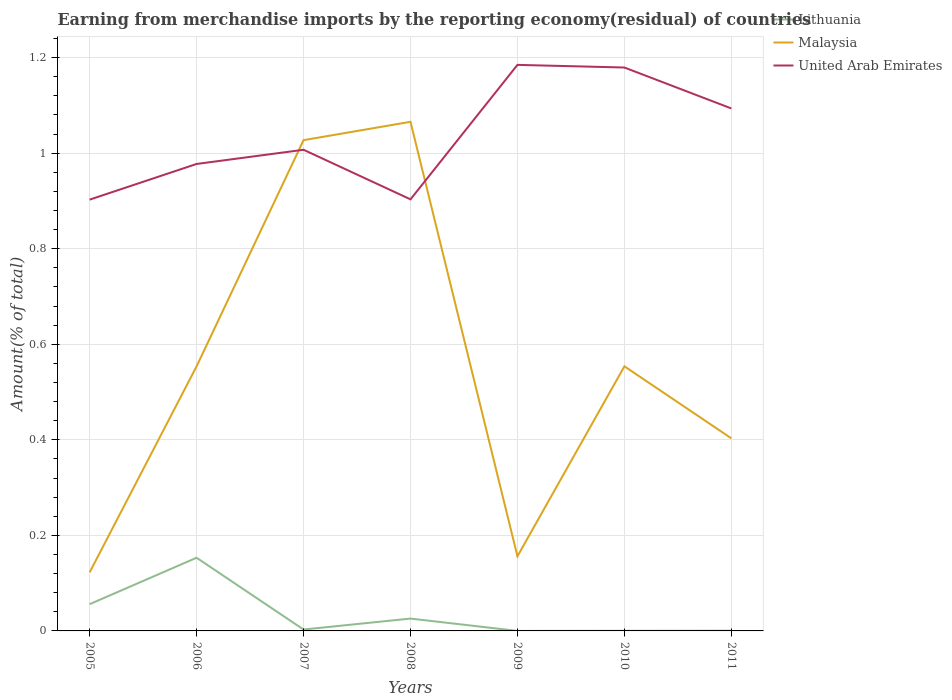How many different coloured lines are there?
Your response must be concise. 3. Does the line corresponding to United Arab Emirates intersect with the line corresponding to Lithuania?
Your answer should be compact. No. Is the number of lines equal to the number of legend labels?
Your answer should be compact. Yes. Across all years, what is the maximum percentage of amount earned from merchandise imports in Malaysia?
Your answer should be compact. 0.12. What is the total percentage of amount earned from merchandise imports in United Arab Emirates in the graph?
Make the answer very short. -0.17. What is the difference between the highest and the second highest percentage of amount earned from merchandise imports in United Arab Emirates?
Provide a short and direct response. 0.28. Is the percentage of amount earned from merchandise imports in Lithuania strictly greater than the percentage of amount earned from merchandise imports in United Arab Emirates over the years?
Offer a terse response. Yes. How many lines are there?
Give a very brief answer. 3. How many years are there in the graph?
Offer a very short reply. 7. What is the difference between two consecutive major ticks on the Y-axis?
Keep it short and to the point. 0.2. Does the graph contain any zero values?
Your answer should be very brief. No. How many legend labels are there?
Offer a terse response. 3. What is the title of the graph?
Offer a terse response. Earning from merchandise imports by the reporting economy(residual) of countries. What is the label or title of the Y-axis?
Your answer should be compact. Amount(% of total). What is the Amount(% of total) in Lithuania in 2005?
Keep it short and to the point. 0.06. What is the Amount(% of total) of Malaysia in 2005?
Provide a short and direct response. 0.12. What is the Amount(% of total) of United Arab Emirates in 2005?
Keep it short and to the point. 0.9. What is the Amount(% of total) of Lithuania in 2006?
Keep it short and to the point. 0.15. What is the Amount(% of total) of Malaysia in 2006?
Give a very brief answer. 0.55. What is the Amount(% of total) in United Arab Emirates in 2006?
Your answer should be very brief. 0.98. What is the Amount(% of total) of Lithuania in 2007?
Provide a short and direct response. 0. What is the Amount(% of total) in Malaysia in 2007?
Make the answer very short. 1.03. What is the Amount(% of total) in United Arab Emirates in 2007?
Offer a terse response. 1.01. What is the Amount(% of total) of Lithuania in 2008?
Your response must be concise. 0.03. What is the Amount(% of total) of Malaysia in 2008?
Your response must be concise. 1.07. What is the Amount(% of total) of United Arab Emirates in 2008?
Give a very brief answer. 0.9. What is the Amount(% of total) in Lithuania in 2009?
Your response must be concise. 1.744827181737909e-5. What is the Amount(% of total) in Malaysia in 2009?
Offer a terse response. 0.16. What is the Amount(% of total) in United Arab Emirates in 2009?
Offer a very short reply. 1.18. What is the Amount(% of total) of Lithuania in 2010?
Offer a terse response. 0. What is the Amount(% of total) of Malaysia in 2010?
Your answer should be compact. 0.55. What is the Amount(% of total) of United Arab Emirates in 2010?
Your response must be concise. 1.18. What is the Amount(% of total) of Lithuania in 2011?
Provide a short and direct response. 0. What is the Amount(% of total) in Malaysia in 2011?
Give a very brief answer. 0.4. What is the Amount(% of total) of United Arab Emirates in 2011?
Make the answer very short. 1.09. Across all years, what is the maximum Amount(% of total) in Lithuania?
Your answer should be compact. 0.15. Across all years, what is the maximum Amount(% of total) of Malaysia?
Your answer should be very brief. 1.07. Across all years, what is the maximum Amount(% of total) in United Arab Emirates?
Provide a succinct answer. 1.18. Across all years, what is the minimum Amount(% of total) in Lithuania?
Offer a very short reply. 1.744827181737909e-5. Across all years, what is the minimum Amount(% of total) in Malaysia?
Keep it short and to the point. 0.12. Across all years, what is the minimum Amount(% of total) of United Arab Emirates?
Your response must be concise. 0.9. What is the total Amount(% of total) of Lithuania in the graph?
Your answer should be compact. 0.24. What is the total Amount(% of total) of Malaysia in the graph?
Keep it short and to the point. 3.88. What is the total Amount(% of total) in United Arab Emirates in the graph?
Your answer should be very brief. 7.25. What is the difference between the Amount(% of total) in Lithuania in 2005 and that in 2006?
Provide a succinct answer. -0.1. What is the difference between the Amount(% of total) of Malaysia in 2005 and that in 2006?
Your response must be concise. -0.43. What is the difference between the Amount(% of total) in United Arab Emirates in 2005 and that in 2006?
Offer a terse response. -0.07. What is the difference between the Amount(% of total) in Lithuania in 2005 and that in 2007?
Provide a succinct answer. 0.05. What is the difference between the Amount(% of total) in Malaysia in 2005 and that in 2007?
Provide a short and direct response. -0.9. What is the difference between the Amount(% of total) in United Arab Emirates in 2005 and that in 2007?
Make the answer very short. -0.1. What is the difference between the Amount(% of total) in Lithuania in 2005 and that in 2008?
Your answer should be compact. 0.03. What is the difference between the Amount(% of total) in Malaysia in 2005 and that in 2008?
Your answer should be very brief. -0.94. What is the difference between the Amount(% of total) of United Arab Emirates in 2005 and that in 2008?
Make the answer very short. -0. What is the difference between the Amount(% of total) in Lithuania in 2005 and that in 2009?
Give a very brief answer. 0.06. What is the difference between the Amount(% of total) in Malaysia in 2005 and that in 2009?
Your answer should be very brief. -0.03. What is the difference between the Amount(% of total) of United Arab Emirates in 2005 and that in 2009?
Keep it short and to the point. -0.28. What is the difference between the Amount(% of total) in Lithuania in 2005 and that in 2010?
Your response must be concise. 0.06. What is the difference between the Amount(% of total) of Malaysia in 2005 and that in 2010?
Give a very brief answer. -0.43. What is the difference between the Amount(% of total) in United Arab Emirates in 2005 and that in 2010?
Provide a short and direct response. -0.28. What is the difference between the Amount(% of total) in Lithuania in 2005 and that in 2011?
Keep it short and to the point. 0.06. What is the difference between the Amount(% of total) in Malaysia in 2005 and that in 2011?
Give a very brief answer. -0.28. What is the difference between the Amount(% of total) in United Arab Emirates in 2005 and that in 2011?
Keep it short and to the point. -0.19. What is the difference between the Amount(% of total) of Lithuania in 2006 and that in 2007?
Ensure brevity in your answer.  0.15. What is the difference between the Amount(% of total) of Malaysia in 2006 and that in 2007?
Make the answer very short. -0.47. What is the difference between the Amount(% of total) in United Arab Emirates in 2006 and that in 2007?
Make the answer very short. -0.03. What is the difference between the Amount(% of total) in Lithuania in 2006 and that in 2008?
Keep it short and to the point. 0.13. What is the difference between the Amount(% of total) in Malaysia in 2006 and that in 2008?
Keep it short and to the point. -0.51. What is the difference between the Amount(% of total) of United Arab Emirates in 2006 and that in 2008?
Give a very brief answer. 0.07. What is the difference between the Amount(% of total) of Lithuania in 2006 and that in 2009?
Keep it short and to the point. 0.15. What is the difference between the Amount(% of total) of Malaysia in 2006 and that in 2009?
Your answer should be compact. 0.4. What is the difference between the Amount(% of total) in United Arab Emirates in 2006 and that in 2009?
Offer a terse response. -0.21. What is the difference between the Amount(% of total) in Lithuania in 2006 and that in 2010?
Offer a terse response. 0.15. What is the difference between the Amount(% of total) of Malaysia in 2006 and that in 2010?
Ensure brevity in your answer.  -0. What is the difference between the Amount(% of total) of United Arab Emirates in 2006 and that in 2010?
Provide a short and direct response. -0.2. What is the difference between the Amount(% of total) of Lithuania in 2006 and that in 2011?
Make the answer very short. 0.15. What is the difference between the Amount(% of total) of Malaysia in 2006 and that in 2011?
Make the answer very short. 0.15. What is the difference between the Amount(% of total) in United Arab Emirates in 2006 and that in 2011?
Offer a very short reply. -0.12. What is the difference between the Amount(% of total) of Lithuania in 2007 and that in 2008?
Give a very brief answer. -0.02. What is the difference between the Amount(% of total) in Malaysia in 2007 and that in 2008?
Your answer should be compact. -0.04. What is the difference between the Amount(% of total) in United Arab Emirates in 2007 and that in 2008?
Give a very brief answer. 0.1. What is the difference between the Amount(% of total) in Lithuania in 2007 and that in 2009?
Provide a succinct answer. 0. What is the difference between the Amount(% of total) of Malaysia in 2007 and that in 2009?
Give a very brief answer. 0.87. What is the difference between the Amount(% of total) of United Arab Emirates in 2007 and that in 2009?
Offer a very short reply. -0.18. What is the difference between the Amount(% of total) in Lithuania in 2007 and that in 2010?
Your answer should be very brief. 0. What is the difference between the Amount(% of total) of Malaysia in 2007 and that in 2010?
Ensure brevity in your answer.  0.47. What is the difference between the Amount(% of total) in United Arab Emirates in 2007 and that in 2010?
Provide a succinct answer. -0.17. What is the difference between the Amount(% of total) of Lithuania in 2007 and that in 2011?
Your answer should be very brief. 0. What is the difference between the Amount(% of total) of Malaysia in 2007 and that in 2011?
Offer a terse response. 0.62. What is the difference between the Amount(% of total) of United Arab Emirates in 2007 and that in 2011?
Provide a short and direct response. -0.09. What is the difference between the Amount(% of total) of Lithuania in 2008 and that in 2009?
Your answer should be very brief. 0.03. What is the difference between the Amount(% of total) of Malaysia in 2008 and that in 2009?
Give a very brief answer. 0.91. What is the difference between the Amount(% of total) in United Arab Emirates in 2008 and that in 2009?
Ensure brevity in your answer.  -0.28. What is the difference between the Amount(% of total) of Lithuania in 2008 and that in 2010?
Keep it short and to the point. 0.03. What is the difference between the Amount(% of total) of Malaysia in 2008 and that in 2010?
Give a very brief answer. 0.51. What is the difference between the Amount(% of total) of United Arab Emirates in 2008 and that in 2010?
Your answer should be compact. -0.28. What is the difference between the Amount(% of total) of Lithuania in 2008 and that in 2011?
Ensure brevity in your answer.  0.03. What is the difference between the Amount(% of total) of Malaysia in 2008 and that in 2011?
Make the answer very short. 0.66. What is the difference between the Amount(% of total) of United Arab Emirates in 2008 and that in 2011?
Your response must be concise. -0.19. What is the difference between the Amount(% of total) of Lithuania in 2009 and that in 2010?
Provide a succinct answer. -0. What is the difference between the Amount(% of total) of Malaysia in 2009 and that in 2010?
Make the answer very short. -0.4. What is the difference between the Amount(% of total) of United Arab Emirates in 2009 and that in 2010?
Ensure brevity in your answer.  0.01. What is the difference between the Amount(% of total) in Lithuania in 2009 and that in 2011?
Offer a terse response. -0. What is the difference between the Amount(% of total) in Malaysia in 2009 and that in 2011?
Your response must be concise. -0.25. What is the difference between the Amount(% of total) of United Arab Emirates in 2009 and that in 2011?
Make the answer very short. 0.09. What is the difference between the Amount(% of total) in Lithuania in 2010 and that in 2011?
Ensure brevity in your answer.  -0. What is the difference between the Amount(% of total) of Malaysia in 2010 and that in 2011?
Your response must be concise. 0.15. What is the difference between the Amount(% of total) in United Arab Emirates in 2010 and that in 2011?
Give a very brief answer. 0.09. What is the difference between the Amount(% of total) in Lithuania in 2005 and the Amount(% of total) in Malaysia in 2006?
Ensure brevity in your answer.  -0.5. What is the difference between the Amount(% of total) of Lithuania in 2005 and the Amount(% of total) of United Arab Emirates in 2006?
Make the answer very short. -0.92. What is the difference between the Amount(% of total) in Malaysia in 2005 and the Amount(% of total) in United Arab Emirates in 2006?
Keep it short and to the point. -0.85. What is the difference between the Amount(% of total) in Lithuania in 2005 and the Amount(% of total) in Malaysia in 2007?
Offer a terse response. -0.97. What is the difference between the Amount(% of total) of Lithuania in 2005 and the Amount(% of total) of United Arab Emirates in 2007?
Provide a short and direct response. -0.95. What is the difference between the Amount(% of total) of Malaysia in 2005 and the Amount(% of total) of United Arab Emirates in 2007?
Provide a succinct answer. -0.88. What is the difference between the Amount(% of total) in Lithuania in 2005 and the Amount(% of total) in Malaysia in 2008?
Make the answer very short. -1.01. What is the difference between the Amount(% of total) in Lithuania in 2005 and the Amount(% of total) in United Arab Emirates in 2008?
Your response must be concise. -0.85. What is the difference between the Amount(% of total) of Malaysia in 2005 and the Amount(% of total) of United Arab Emirates in 2008?
Your answer should be compact. -0.78. What is the difference between the Amount(% of total) of Lithuania in 2005 and the Amount(% of total) of Malaysia in 2009?
Keep it short and to the point. -0.1. What is the difference between the Amount(% of total) of Lithuania in 2005 and the Amount(% of total) of United Arab Emirates in 2009?
Offer a terse response. -1.13. What is the difference between the Amount(% of total) in Malaysia in 2005 and the Amount(% of total) in United Arab Emirates in 2009?
Give a very brief answer. -1.06. What is the difference between the Amount(% of total) in Lithuania in 2005 and the Amount(% of total) in Malaysia in 2010?
Provide a succinct answer. -0.5. What is the difference between the Amount(% of total) in Lithuania in 2005 and the Amount(% of total) in United Arab Emirates in 2010?
Ensure brevity in your answer.  -1.12. What is the difference between the Amount(% of total) of Malaysia in 2005 and the Amount(% of total) of United Arab Emirates in 2010?
Offer a terse response. -1.06. What is the difference between the Amount(% of total) of Lithuania in 2005 and the Amount(% of total) of Malaysia in 2011?
Give a very brief answer. -0.35. What is the difference between the Amount(% of total) of Lithuania in 2005 and the Amount(% of total) of United Arab Emirates in 2011?
Give a very brief answer. -1.04. What is the difference between the Amount(% of total) in Malaysia in 2005 and the Amount(% of total) in United Arab Emirates in 2011?
Make the answer very short. -0.97. What is the difference between the Amount(% of total) in Lithuania in 2006 and the Amount(% of total) in Malaysia in 2007?
Keep it short and to the point. -0.87. What is the difference between the Amount(% of total) in Lithuania in 2006 and the Amount(% of total) in United Arab Emirates in 2007?
Give a very brief answer. -0.85. What is the difference between the Amount(% of total) in Malaysia in 2006 and the Amount(% of total) in United Arab Emirates in 2007?
Ensure brevity in your answer.  -0.45. What is the difference between the Amount(% of total) in Lithuania in 2006 and the Amount(% of total) in Malaysia in 2008?
Your answer should be compact. -0.91. What is the difference between the Amount(% of total) in Lithuania in 2006 and the Amount(% of total) in United Arab Emirates in 2008?
Your response must be concise. -0.75. What is the difference between the Amount(% of total) in Malaysia in 2006 and the Amount(% of total) in United Arab Emirates in 2008?
Your answer should be compact. -0.35. What is the difference between the Amount(% of total) in Lithuania in 2006 and the Amount(% of total) in Malaysia in 2009?
Your answer should be very brief. -0. What is the difference between the Amount(% of total) in Lithuania in 2006 and the Amount(% of total) in United Arab Emirates in 2009?
Keep it short and to the point. -1.03. What is the difference between the Amount(% of total) in Malaysia in 2006 and the Amount(% of total) in United Arab Emirates in 2009?
Your answer should be compact. -0.63. What is the difference between the Amount(% of total) of Lithuania in 2006 and the Amount(% of total) of Malaysia in 2010?
Make the answer very short. -0.4. What is the difference between the Amount(% of total) in Lithuania in 2006 and the Amount(% of total) in United Arab Emirates in 2010?
Offer a terse response. -1.03. What is the difference between the Amount(% of total) of Malaysia in 2006 and the Amount(% of total) of United Arab Emirates in 2010?
Your answer should be compact. -0.63. What is the difference between the Amount(% of total) in Lithuania in 2006 and the Amount(% of total) in Malaysia in 2011?
Give a very brief answer. -0.25. What is the difference between the Amount(% of total) in Lithuania in 2006 and the Amount(% of total) in United Arab Emirates in 2011?
Offer a terse response. -0.94. What is the difference between the Amount(% of total) of Malaysia in 2006 and the Amount(% of total) of United Arab Emirates in 2011?
Make the answer very short. -0.54. What is the difference between the Amount(% of total) in Lithuania in 2007 and the Amount(% of total) in Malaysia in 2008?
Offer a very short reply. -1.06. What is the difference between the Amount(% of total) of Lithuania in 2007 and the Amount(% of total) of United Arab Emirates in 2008?
Keep it short and to the point. -0.9. What is the difference between the Amount(% of total) of Malaysia in 2007 and the Amount(% of total) of United Arab Emirates in 2008?
Offer a terse response. 0.12. What is the difference between the Amount(% of total) of Lithuania in 2007 and the Amount(% of total) of Malaysia in 2009?
Your response must be concise. -0.15. What is the difference between the Amount(% of total) in Lithuania in 2007 and the Amount(% of total) in United Arab Emirates in 2009?
Your response must be concise. -1.18. What is the difference between the Amount(% of total) of Malaysia in 2007 and the Amount(% of total) of United Arab Emirates in 2009?
Give a very brief answer. -0.16. What is the difference between the Amount(% of total) of Lithuania in 2007 and the Amount(% of total) of Malaysia in 2010?
Offer a very short reply. -0.55. What is the difference between the Amount(% of total) of Lithuania in 2007 and the Amount(% of total) of United Arab Emirates in 2010?
Give a very brief answer. -1.18. What is the difference between the Amount(% of total) of Malaysia in 2007 and the Amount(% of total) of United Arab Emirates in 2010?
Ensure brevity in your answer.  -0.15. What is the difference between the Amount(% of total) in Lithuania in 2007 and the Amount(% of total) in Malaysia in 2011?
Offer a very short reply. -0.4. What is the difference between the Amount(% of total) in Lithuania in 2007 and the Amount(% of total) in United Arab Emirates in 2011?
Make the answer very short. -1.09. What is the difference between the Amount(% of total) in Malaysia in 2007 and the Amount(% of total) in United Arab Emirates in 2011?
Keep it short and to the point. -0.07. What is the difference between the Amount(% of total) of Lithuania in 2008 and the Amount(% of total) of Malaysia in 2009?
Keep it short and to the point. -0.13. What is the difference between the Amount(% of total) in Lithuania in 2008 and the Amount(% of total) in United Arab Emirates in 2009?
Give a very brief answer. -1.16. What is the difference between the Amount(% of total) of Malaysia in 2008 and the Amount(% of total) of United Arab Emirates in 2009?
Your answer should be compact. -0.12. What is the difference between the Amount(% of total) of Lithuania in 2008 and the Amount(% of total) of Malaysia in 2010?
Your response must be concise. -0.53. What is the difference between the Amount(% of total) in Lithuania in 2008 and the Amount(% of total) in United Arab Emirates in 2010?
Make the answer very short. -1.15. What is the difference between the Amount(% of total) in Malaysia in 2008 and the Amount(% of total) in United Arab Emirates in 2010?
Your answer should be compact. -0.11. What is the difference between the Amount(% of total) in Lithuania in 2008 and the Amount(% of total) in Malaysia in 2011?
Provide a short and direct response. -0.38. What is the difference between the Amount(% of total) in Lithuania in 2008 and the Amount(% of total) in United Arab Emirates in 2011?
Your answer should be compact. -1.07. What is the difference between the Amount(% of total) in Malaysia in 2008 and the Amount(% of total) in United Arab Emirates in 2011?
Provide a succinct answer. -0.03. What is the difference between the Amount(% of total) in Lithuania in 2009 and the Amount(% of total) in Malaysia in 2010?
Your answer should be compact. -0.55. What is the difference between the Amount(% of total) in Lithuania in 2009 and the Amount(% of total) in United Arab Emirates in 2010?
Provide a short and direct response. -1.18. What is the difference between the Amount(% of total) in Malaysia in 2009 and the Amount(% of total) in United Arab Emirates in 2010?
Ensure brevity in your answer.  -1.02. What is the difference between the Amount(% of total) of Lithuania in 2009 and the Amount(% of total) of Malaysia in 2011?
Your response must be concise. -0.4. What is the difference between the Amount(% of total) of Lithuania in 2009 and the Amount(% of total) of United Arab Emirates in 2011?
Provide a short and direct response. -1.09. What is the difference between the Amount(% of total) of Malaysia in 2009 and the Amount(% of total) of United Arab Emirates in 2011?
Make the answer very short. -0.94. What is the difference between the Amount(% of total) in Lithuania in 2010 and the Amount(% of total) in Malaysia in 2011?
Keep it short and to the point. -0.4. What is the difference between the Amount(% of total) of Lithuania in 2010 and the Amount(% of total) of United Arab Emirates in 2011?
Make the answer very short. -1.09. What is the difference between the Amount(% of total) in Malaysia in 2010 and the Amount(% of total) in United Arab Emirates in 2011?
Ensure brevity in your answer.  -0.54. What is the average Amount(% of total) of Lithuania per year?
Ensure brevity in your answer.  0.03. What is the average Amount(% of total) of Malaysia per year?
Make the answer very short. 0.55. What is the average Amount(% of total) of United Arab Emirates per year?
Offer a terse response. 1.04. In the year 2005, what is the difference between the Amount(% of total) in Lithuania and Amount(% of total) in Malaysia?
Provide a short and direct response. -0.07. In the year 2005, what is the difference between the Amount(% of total) in Lithuania and Amount(% of total) in United Arab Emirates?
Provide a short and direct response. -0.85. In the year 2005, what is the difference between the Amount(% of total) in Malaysia and Amount(% of total) in United Arab Emirates?
Your answer should be compact. -0.78. In the year 2006, what is the difference between the Amount(% of total) in Lithuania and Amount(% of total) in Malaysia?
Ensure brevity in your answer.  -0.4. In the year 2006, what is the difference between the Amount(% of total) of Lithuania and Amount(% of total) of United Arab Emirates?
Keep it short and to the point. -0.82. In the year 2006, what is the difference between the Amount(% of total) in Malaysia and Amount(% of total) in United Arab Emirates?
Give a very brief answer. -0.42. In the year 2007, what is the difference between the Amount(% of total) in Lithuania and Amount(% of total) in Malaysia?
Provide a succinct answer. -1.02. In the year 2007, what is the difference between the Amount(% of total) of Lithuania and Amount(% of total) of United Arab Emirates?
Give a very brief answer. -1. In the year 2007, what is the difference between the Amount(% of total) in Malaysia and Amount(% of total) in United Arab Emirates?
Provide a succinct answer. 0.02. In the year 2008, what is the difference between the Amount(% of total) of Lithuania and Amount(% of total) of Malaysia?
Your answer should be compact. -1.04. In the year 2008, what is the difference between the Amount(% of total) of Lithuania and Amount(% of total) of United Arab Emirates?
Your answer should be compact. -0.88. In the year 2008, what is the difference between the Amount(% of total) in Malaysia and Amount(% of total) in United Arab Emirates?
Your answer should be compact. 0.16. In the year 2009, what is the difference between the Amount(% of total) of Lithuania and Amount(% of total) of Malaysia?
Your answer should be compact. -0.16. In the year 2009, what is the difference between the Amount(% of total) in Lithuania and Amount(% of total) in United Arab Emirates?
Offer a very short reply. -1.18. In the year 2009, what is the difference between the Amount(% of total) in Malaysia and Amount(% of total) in United Arab Emirates?
Your answer should be compact. -1.03. In the year 2010, what is the difference between the Amount(% of total) in Lithuania and Amount(% of total) in Malaysia?
Keep it short and to the point. -0.55. In the year 2010, what is the difference between the Amount(% of total) of Lithuania and Amount(% of total) of United Arab Emirates?
Offer a very short reply. -1.18. In the year 2010, what is the difference between the Amount(% of total) of Malaysia and Amount(% of total) of United Arab Emirates?
Make the answer very short. -0.63. In the year 2011, what is the difference between the Amount(% of total) in Lithuania and Amount(% of total) in Malaysia?
Make the answer very short. -0.4. In the year 2011, what is the difference between the Amount(% of total) in Lithuania and Amount(% of total) in United Arab Emirates?
Provide a succinct answer. -1.09. In the year 2011, what is the difference between the Amount(% of total) of Malaysia and Amount(% of total) of United Arab Emirates?
Keep it short and to the point. -0.69. What is the ratio of the Amount(% of total) in Lithuania in 2005 to that in 2006?
Give a very brief answer. 0.37. What is the ratio of the Amount(% of total) in Malaysia in 2005 to that in 2006?
Your answer should be compact. 0.22. What is the ratio of the Amount(% of total) of United Arab Emirates in 2005 to that in 2006?
Your answer should be compact. 0.92. What is the ratio of the Amount(% of total) in Lithuania in 2005 to that in 2007?
Provide a short and direct response. 19.18. What is the ratio of the Amount(% of total) in Malaysia in 2005 to that in 2007?
Offer a terse response. 0.12. What is the ratio of the Amount(% of total) in United Arab Emirates in 2005 to that in 2007?
Your answer should be very brief. 0.9. What is the ratio of the Amount(% of total) of Lithuania in 2005 to that in 2008?
Provide a short and direct response. 2.17. What is the ratio of the Amount(% of total) of Malaysia in 2005 to that in 2008?
Offer a very short reply. 0.12. What is the ratio of the Amount(% of total) in United Arab Emirates in 2005 to that in 2008?
Provide a succinct answer. 1. What is the ratio of the Amount(% of total) of Lithuania in 2005 to that in 2009?
Give a very brief answer. 3208.12. What is the ratio of the Amount(% of total) in Malaysia in 2005 to that in 2009?
Keep it short and to the point. 0.78. What is the ratio of the Amount(% of total) of United Arab Emirates in 2005 to that in 2009?
Your response must be concise. 0.76. What is the ratio of the Amount(% of total) of Lithuania in 2005 to that in 2010?
Your answer should be very brief. 193.83. What is the ratio of the Amount(% of total) in Malaysia in 2005 to that in 2010?
Provide a short and direct response. 0.22. What is the ratio of the Amount(% of total) in United Arab Emirates in 2005 to that in 2010?
Your answer should be compact. 0.77. What is the ratio of the Amount(% of total) of Lithuania in 2005 to that in 2011?
Your answer should be very brief. 126.49. What is the ratio of the Amount(% of total) in Malaysia in 2005 to that in 2011?
Provide a succinct answer. 0.3. What is the ratio of the Amount(% of total) of United Arab Emirates in 2005 to that in 2011?
Keep it short and to the point. 0.83. What is the ratio of the Amount(% of total) in Lithuania in 2006 to that in 2007?
Give a very brief answer. 52.48. What is the ratio of the Amount(% of total) in Malaysia in 2006 to that in 2007?
Give a very brief answer. 0.54. What is the ratio of the Amount(% of total) of United Arab Emirates in 2006 to that in 2007?
Ensure brevity in your answer.  0.97. What is the ratio of the Amount(% of total) in Lithuania in 2006 to that in 2008?
Give a very brief answer. 5.93. What is the ratio of the Amount(% of total) of Malaysia in 2006 to that in 2008?
Offer a terse response. 0.52. What is the ratio of the Amount(% of total) in United Arab Emirates in 2006 to that in 2008?
Your answer should be compact. 1.08. What is the ratio of the Amount(% of total) in Lithuania in 2006 to that in 2009?
Offer a terse response. 8778.02. What is the ratio of the Amount(% of total) in Malaysia in 2006 to that in 2009?
Ensure brevity in your answer.  3.55. What is the ratio of the Amount(% of total) in United Arab Emirates in 2006 to that in 2009?
Provide a short and direct response. 0.82. What is the ratio of the Amount(% of total) of Lithuania in 2006 to that in 2010?
Give a very brief answer. 530.36. What is the ratio of the Amount(% of total) of United Arab Emirates in 2006 to that in 2010?
Your answer should be very brief. 0.83. What is the ratio of the Amount(% of total) of Lithuania in 2006 to that in 2011?
Offer a very short reply. 346.11. What is the ratio of the Amount(% of total) in Malaysia in 2006 to that in 2011?
Ensure brevity in your answer.  1.37. What is the ratio of the Amount(% of total) of United Arab Emirates in 2006 to that in 2011?
Provide a short and direct response. 0.89. What is the ratio of the Amount(% of total) of Lithuania in 2007 to that in 2008?
Offer a very short reply. 0.11. What is the ratio of the Amount(% of total) in Malaysia in 2007 to that in 2008?
Your answer should be compact. 0.96. What is the ratio of the Amount(% of total) of United Arab Emirates in 2007 to that in 2008?
Offer a very short reply. 1.11. What is the ratio of the Amount(% of total) in Lithuania in 2007 to that in 2009?
Your response must be concise. 167.28. What is the ratio of the Amount(% of total) in Malaysia in 2007 to that in 2009?
Your answer should be very brief. 6.58. What is the ratio of the Amount(% of total) in United Arab Emirates in 2007 to that in 2009?
Offer a terse response. 0.85. What is the ratio of the Amount(% of total) of Lithuania in 2007 to that in 2010?
Provide a short and direct response. 10.11. What is the ratio of the Amount(% of total) of Malaysia in 2007 to that in 2010?
Offer a terse response. 1.85. What is the ratio of the Amount(% of total) in United Arab Emirates in 2007 to that in 2010?
Ensure brevity in your answer.  0.85. What is the ratio of the Amount(% of total) of Lithuania in 2007 to that in 2011?
Provide a short and direct response. 6.6. What is the ratio of the Amount(% of total) of Malaysia in 2007 to that in 2011?
Give a very brief answer. 2.55. What is the ratio of the Amount(% of total) in United Arab Emirates in 2007 to that in 2011?
Your answer should be compact. 0.92. What is the ratio of the Amount(% of total) in Lithuania in 2008 to that in 2009?
Keep it short and to the point. 1481.28. What is the ratio of the Amount(% of total) of Malaysia in 2008 to that in 2009?
Your answer should be compact. 6.82. What is the ratio of the Amount(% of total) of United Arab Emirates in 2008 to that in 2009?
Provide a succinct answer. 0.76. What is the ratio of the Amount(% of total) in Lithuania in 2008 to that in 2010?
Your answer should be compact. 89.5. What is the ratio of the Amount(% of total) of Malaysia in 2008 to that in 2010?
Make the answer very short. 1.92. What is the ratio of the Amount(% of total) of United Arab Emirates in 2008 to that in 2010?
Offer a terse response. 0.77. What is the ratio of the Amount(% of total) of Lithuania in 2008 to that in 2011?
Keep it short and to the point. 58.41. What is the ratio of the Amount(% of total) of Malaysia in 2008 to that in 2011?
Your response must be concise. 2.64. What is the ratio of the Amount(% of total) in United Arab Emirates in 2008 to that in 2011?
Keep it short and to the point. 0.83. What is the ratio of the Amount(% of total) in Lithuania in 2009 to that in 2010?
Make the answer very short. 0.06. What is the ratio of the Amount(% of total) of Malaysia in 2009 to that in 2010?
Give a very brief answer. 0.28. What is the ratio of the Amount(% of total) in Lithuania in 2009 to that in 2011?
Offer a very short reply. 0.04. What is the ratio of the Amount(% of total) of Malaysia in 2009 to that in 2011?
Your answer should be compact. 0.39. What is the ratio of the Amount(% of total) in United Arab Emirates in 2009 to that in 2011?
Give a very brief answer. 1.08. What is the ratio of the Amount(% of total) in Lithuania in 2010 to that in 2011?
Give a very brief answer. 0.65. What is the ratio of the Amount(% of total) in Malaysia in 2010 to that in 2011?
Make the answer very short. 1.37. What is the ratio of the Amount(% of total) in United Arab Emirates in 2010 to that in 2011?
Keep it short and to the point. 1.08. What is the difference between the highest and the second highest Amount(% of total) of Lithuania?
Offer a very short reply. 0.1. What is the difference between the highest and the second highest Amount(% of total) in Malaysia?
Give a very brief answer. 0.04. What is the difference between the highest and the second highest Amount(% of total) of United Arab Emirates?
Ensure brevity in your answer.  0.01. What is the difference between the highest and the lowest Amount(% of total) of Lithuania?
Make the answer very short. 0.15. What is the difference between the highest and the lowest Amount(% of total) in Malaysia?
Offer a very short reply. 0.94. What is the difference between the highest and the lowest Amount(% of total) in United Arab Emirates?
Provide a succinct answer. 0.28. 